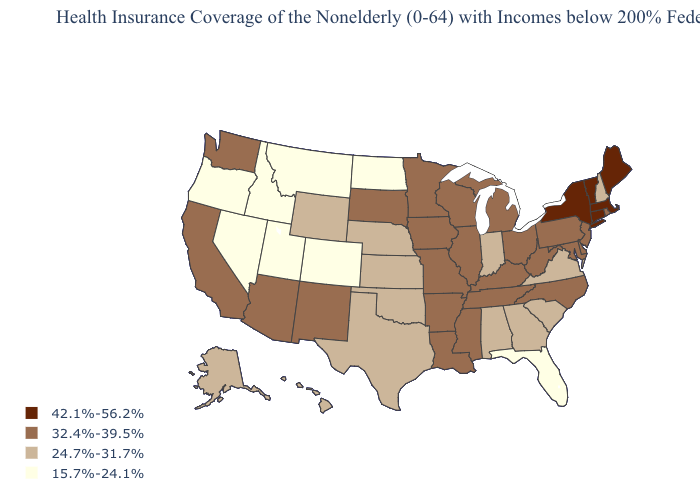Does Arkansas have a higher value than Georgia?
Write a very short answer. Yes. Name the states that have a value in the range 15.7%-24.1%?
Write a very short answer. Colorado, Florida, Idaho, Montana, Nevada, North Dakota, Oregon, Utah. Does Idaho have the lowest value in the USA?
Answer briefly. Yes. Does Florida have the lowest value in the USA?
Answer briefly. Yes. Among the states that border Illinois , does Missouri have the highest value?
Give a very brief answer. Yes. What is the value of Missouri?
Concise answer only. 32.4%-39.5%. Name the states that have a value in the range 24.7%-31.7%?
Keep it brief. Alabama, Alaska, Georgia, Hawaii, Indiana, Kansas, Nebraska, New Hampshire, Oklahoma, South Carolina, Texas, Virginia, Wyoming. Does South Carolina have the same value as New Mexico?
Write a very short answer. No. What is the lowest value in the MidWest?
Keep it brief. 15.7%-24.1%. Among the states that border Colorado , does Arizona have the highest value?
Keep it brief. Yes. Name the states that have a value in the range 42.1%-56.2%?
Answer briefly. Connecticut, Maine, Massachusetts, New York, Vermont. Name the states that have a value in the range 42.1%-56.2%?
Give a very brief answer. Connecticut, Maine, Massachusetts, New York, Vermont. What is the value of Vermont?
Be succinct. 42.1%-56.2%. Name the states that have a value in the range 24.7%-31.7%?
Short answer required. Alabama, Alaska, Georgia, Hawaii, Indiana, Kansas, Nebraska, New Hampshire, Oklahoma, South Carolina, Texas, Virginia, Wyoming. Name the states that have a value in the range 15.7%-24.1%?
Keep it brief. Colorado, Florida, Idaho, Montana, Nevada, North Dakota, Oregon, Utah. 